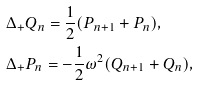<formula> <loc_0><loc_0><loc_500><loc_500>& \Delta _ { + } Q _ { n } = \frac { 1 } { 2 } ( P _ { n + 1 } + P _ { n } ) , \\ & \Delta _ { + } P _ { n } = - \frac { 1 } { 2 } \omega ^ { 2 } ( Q _ { n + 1 } + Q _ { n } ) ,</formula> 